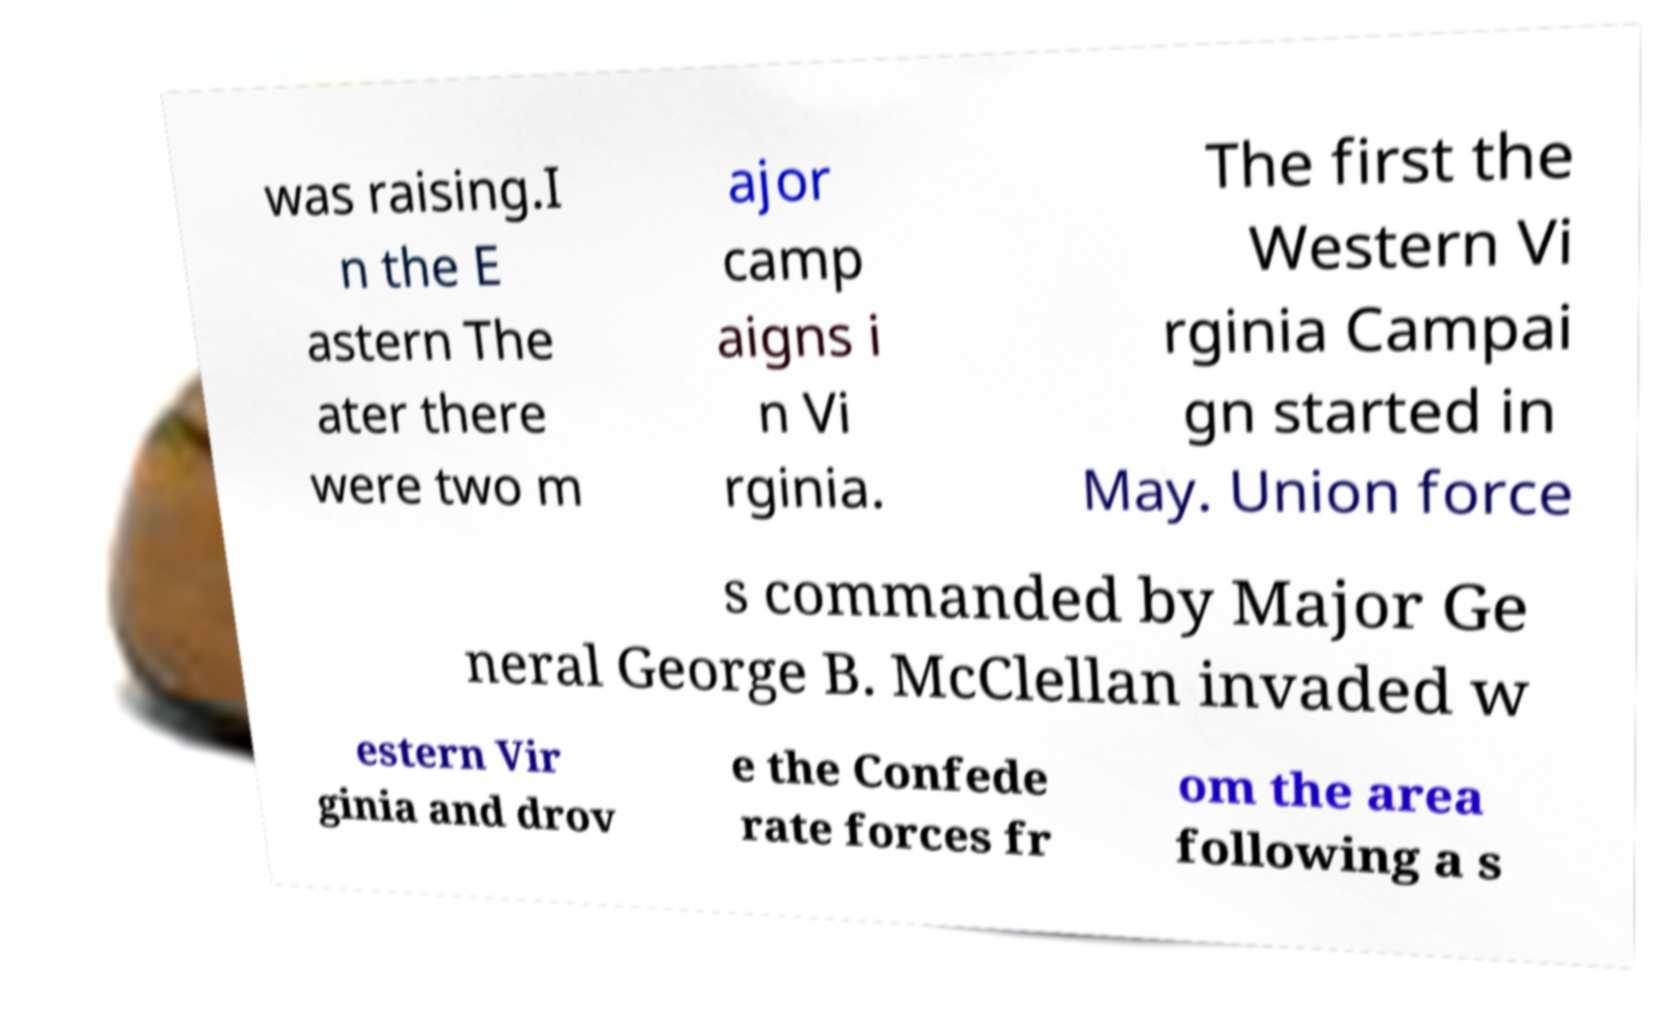Can you read and provide the text displayed in the image?This photo seems to have some interesting text. Can you extract and type it out for me? was raising.I n the E astern The ater there were two m ajor camp aigns i n Vi rginia. The first the Western Vi rginia Campai gn started in May. Union force s commanded by Major Ge neral George B. McClellan invaded w estern Vir ginia and drov e the Confede rate forces fr om the area following a s 